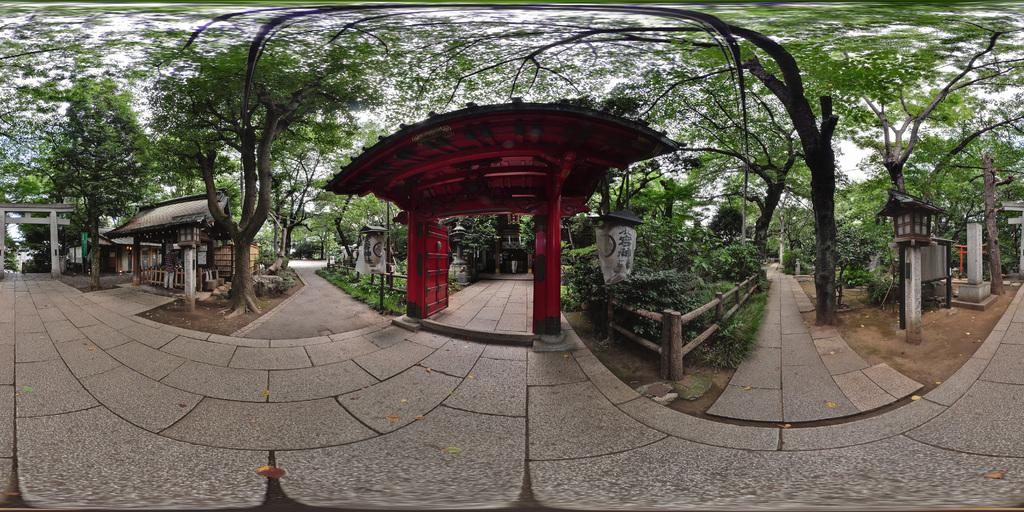What type of vegetation can be seen in the image? There are trees and plants in the image. What kind of structure is present in the image? There is an arch in the image. What type of lettuce is growing on the arch in the image? There is no lettuce present in the image, and the arch is not a structure that would typically support plant growth. 